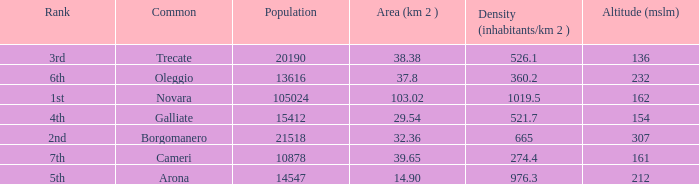What is the minimum altitude (mslm) in all the commons? 136.0. 